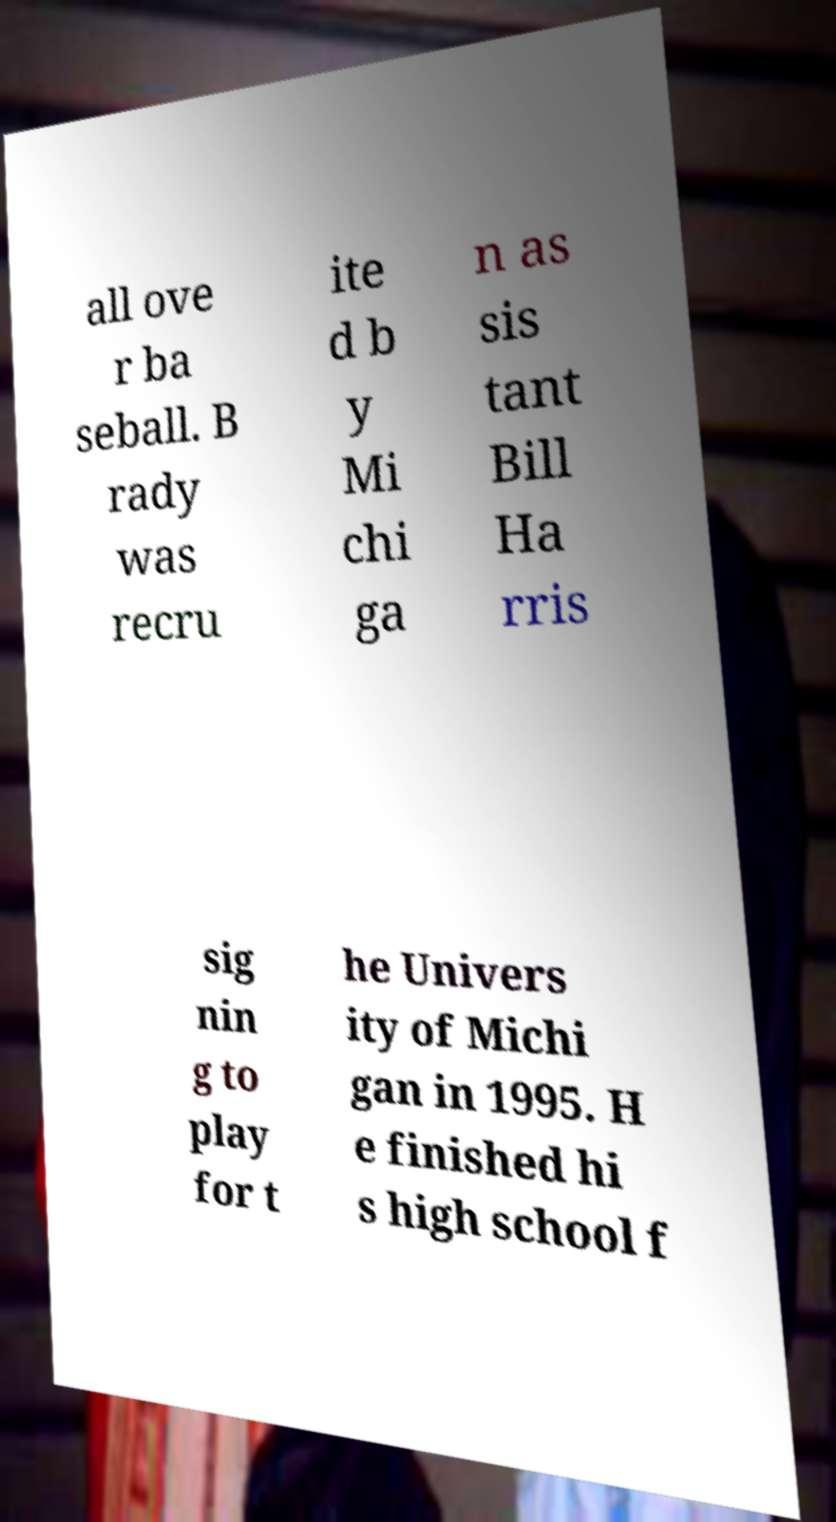I need the written content from this picture converted into text. Can you do that? all ove r ba seball. B rady was recru ite d b y Mi chi ga n as sis tant Bill Ha rris sig nin g to play for t he Univers ity of Michi gan in 1995. H e finished hi s high school f 